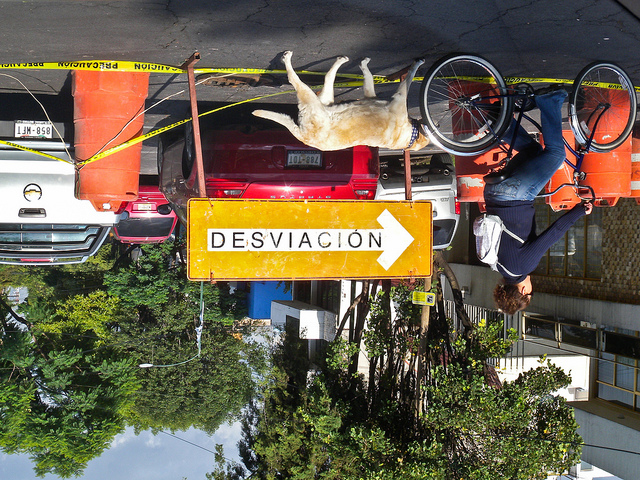Identify and read out the text in this image. DESVIACION PRECAUCION 